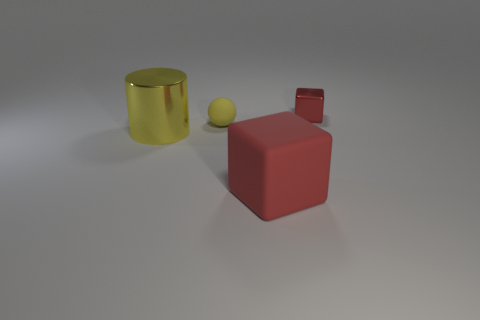There is a block that is left of the metal thing on the right side of the large red matte block; what is its material?
Ensure brevity in your answer.  Rubber. Does the large red matte object have the same shape as the red metal object?
Keep it short and to the point. Yes. What color is the matte thing that is the same size as the metal cube?
Ensure brevity in your answer.  Yellow. Are there any tiny balls of the same color as the large cube?
Give a very brief answer. No. Are there any tiny cyan spheres?
Offer a terse response. No. Is the red thing in front of the tiny red metal object made of the same material as the yellow ball?
Your response must be concise. Yes. There is a thing that is the same color as the small sphere; what is its size?
Make the answer very short. Large. How many other yellow spheres are the same size as the yellow rubber ball?
Keep it short and to the point. 0. Are there the same number of big shiny objects that are in front of the large yellow cylinder and large blue metallic balls?
Keep it short and to the point. Yes. How many things are on the left side of the small cube and behind the large metallic cylinder?
Give a very brief answer. 1. 